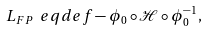<formula> <loc_0><loc_0><loc_500><loc_500>L _ { F P } \ e q d e f - \phi _ { 0 } \circ \mathcal { H } \circ \phi _ { 0 } ^ { - 1 } ,</formula> 